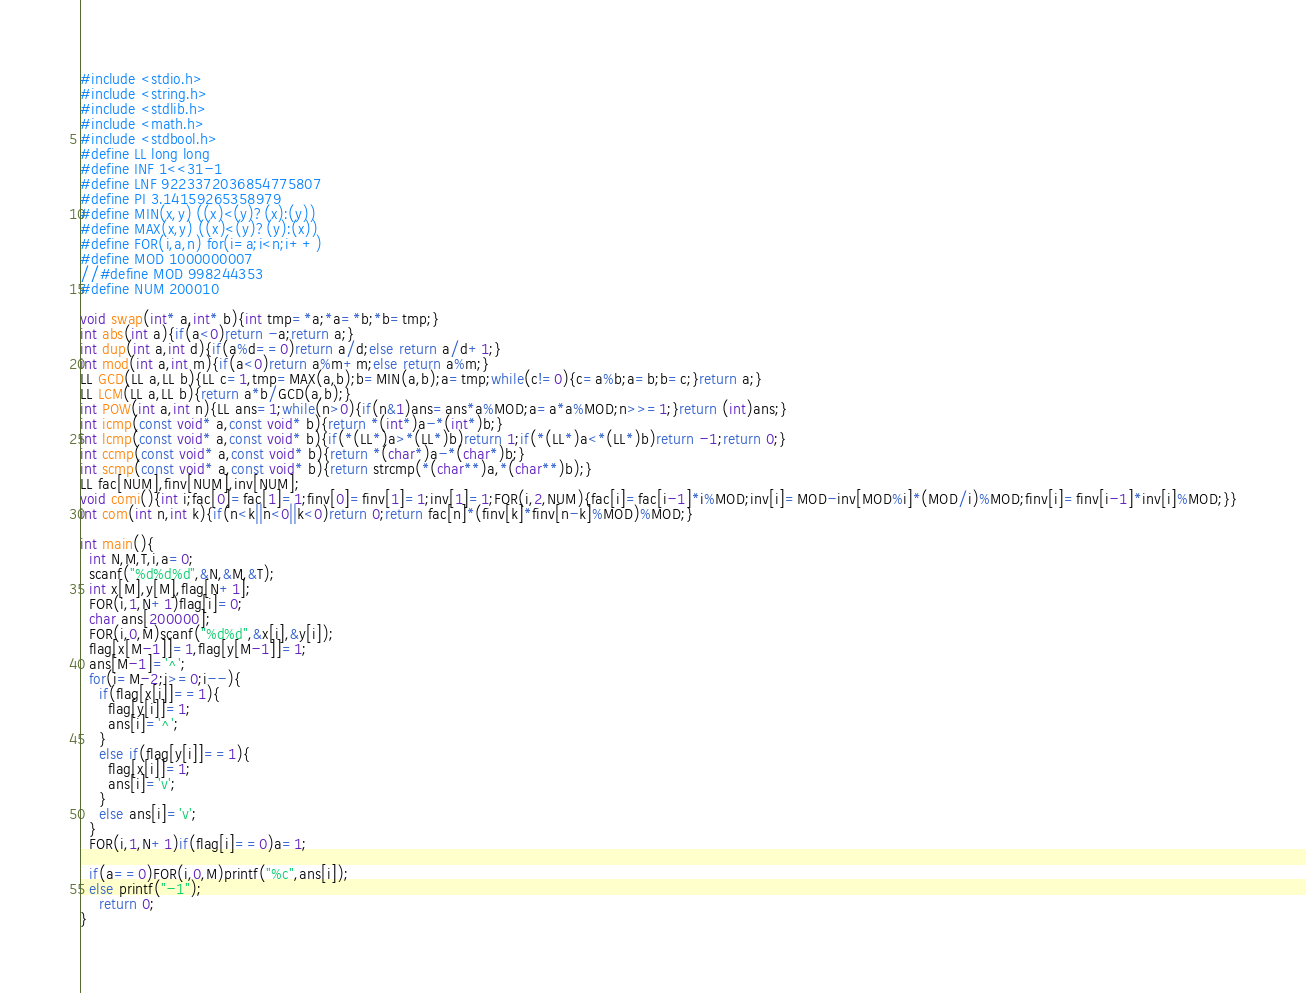<code> <loc_0><loc_0><loc_500><loc_500><_C_>#include <stdio.h>
#include <string.h>
#include <stdlib.h>
#include <math.h>
#include <stdbool.h>
#define LL long long
#define INF 1<<31-1
#define LNF 9223372036854775807
#define PI 3.14159265358979
#define MIN(x,y) ((x)<(y)?(x):(y))
#define MAX(x,y) ((x)<(y)?(y):(x))
#define FOR(i,a,n) for(i=a;i<n;i++)
#define MOD 1000000007
//#define MOD 998244353
#define NUM 200010

void swap(int* a,int* b){int tmp=*a;*a=*b;*b=tmp;}
int abs(int a){if(a<0)return -a;return a;}
int dup(int a,int d){if(a%d==0)return a/d;else return a/d+1;}
int mod(int a,int m){if(a<0)return a%m+m;else return a%m;}
LL GCD(LL a,LL b){LL c=1,tmp=MAX(a,b);b=MIN(a,b);a=tmp;while(c!=0){c=a%b;a=b;b=c;}return a;}
LL LCM(LL a,LL b){return a*b/GCD(a,b);}
int POW(int a,int n){LL ans=1;while(n>0){if(n&1)ans=ans*a%MOD;a=a*a%MOD;n>>=1;}return (int)ans;}
int icmp(const void* a,const void* b){return *(int*)a-*(int*)b;}
int lcmp(const void* a,const void* b){if(*(LL*)a>*(LL*)b)return 1;if(*(LL*)a<*(LL*)b)return -1;return 0;}
int ccmp(const void* a,const void* b){return *(char*)a-*(char*)b;}
int scmp(const void* a,const void* b){return strcmp(*(char**)a,*(char**)b);}
LL fac[NUM],finv[NUM],inv[NUM];
void comi(){int i;fac[0]=fac[1]=1;finv[0]=finv[1]=1;inv[1]=1;FOR(i,2,NUM){fac[i]=fac[i-1]*i%MOD;inv[i]=MOD-inv[MOD%i]*(MOD/i)%MOD;finv[i]=finv[i-1]*inv[i]%MOD;}}
int com(int n,int k){if(n<k||n<0||k<0)return 0;return fac[n]*(finv[k]*finv[n-k]%MOD)%MOD;}

int main(){
  int N,M,T,i,a=0;
  scanf("%d%d%d",&N,&M,&T);
  int x[M],y[M],flag[N+1];
  FOR(i,1,N+1)flag[i]=0;
  char ans[200000];
  FOR(i,0,M)scanf("%d%d",&x[i],&y[i]);
  flag[x[M-1]]=1,flag[y[M-1]]=1;
  ans[M-1]='^';
  for(i=M-2;i>=0;i--){
    if(flag[x[i]]==1){
      flag[y[i]]=1;
      ans[i]='^';
    }
    else if(flag[y[i]]==1){
      flag[x[i]]=1;
      ans[i]='v';
    }
    else ans[i]='v';
  }
  FOR(i,1,N+1)if(flag[i]==0)a=1;

  if(a==0)FOR(i,0,M)printf("%c",ans[i]);
  else printf("-1");
	return 0;
}
</code> 